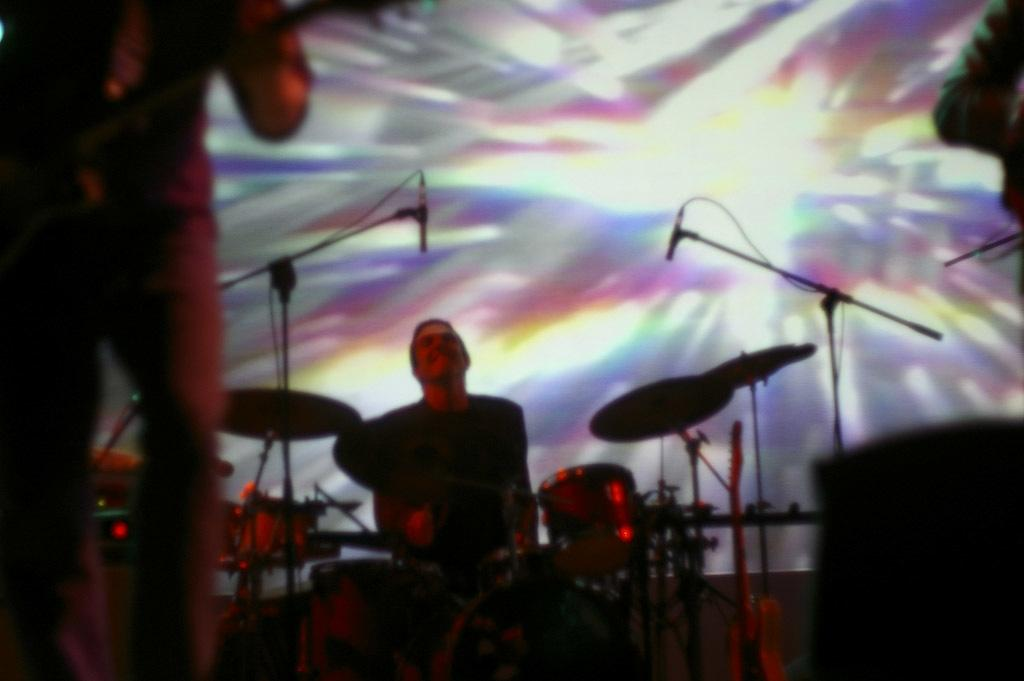What activity is the person on the left side of the image engaged in? The person on the left side of the image is playing a guitar. What instrument is the person on the right side of the image playing? The person on the right side of the image is playing drums. What objects are present in the image to amplify sound? There are microphones with stands in the image. Can you describe the position of the guitar in the image? The guitar is placed on the right side of the image. What level of education does the person's uncle have in the image? There is no information about the person's uncle or their level of education in the image. 